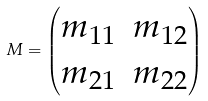Convert formula to latex. <formula><loc_0><loc_0><loc_500><loc_500>M = \begin{pmatrix} m _ { 1 1 } & m _ { 1 2 } \\ m _ { 2 1 } & m _ { 2 2 } \\ \end{pmatrix}</formula> 